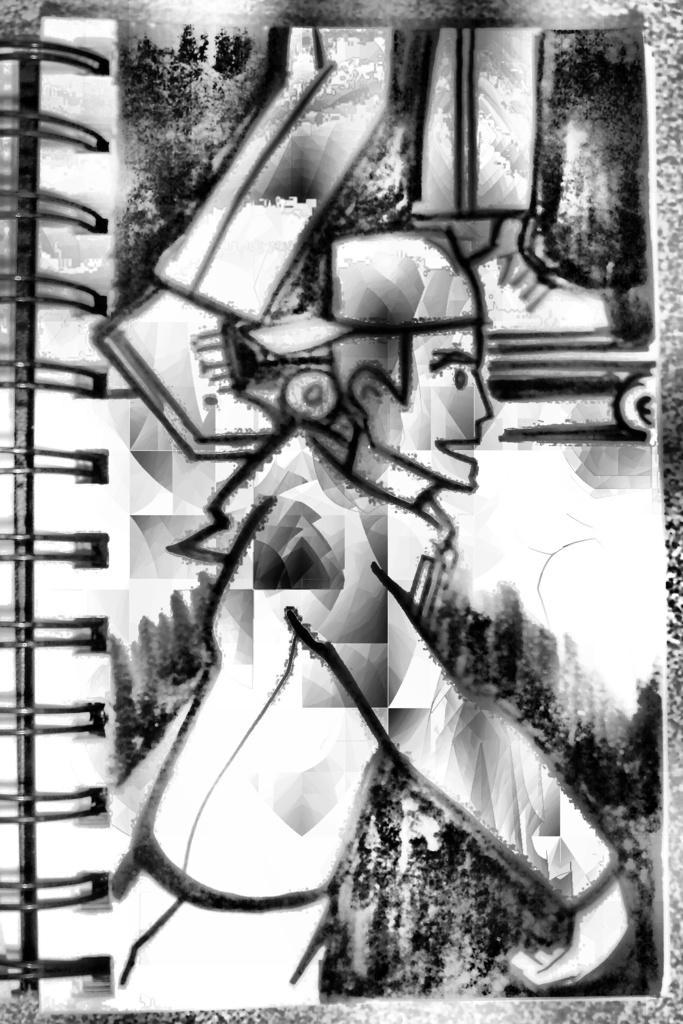Could you give a brief overview of what you see in this image? In this picture I can observe a sketch on the paper. This is a sketch of a person. The sketch is in black color. On the left side I can observe spiral binding. 